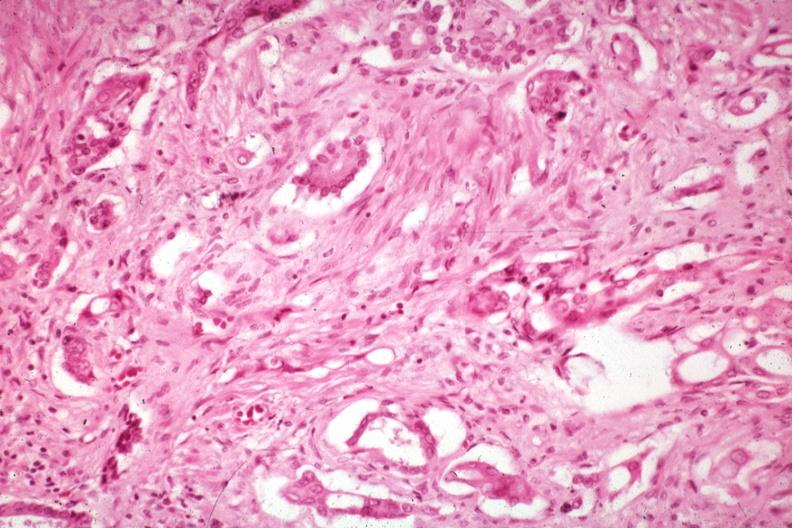does this image show anaplastic carcinoma with desmoplasia large myofibroblastic cell are prominent in the stroma?
Answer the question using a single word or phrase. Yes 